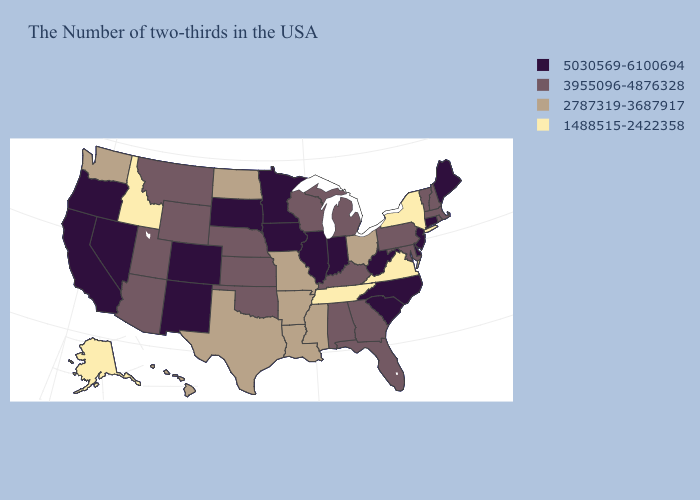Which states hav the highest value in the West?
Keep it brief. Colorado, New Mexico, Nevada, California, Oregon. What is the lowest value in the South?
Be succinct. 1488515-2422358. Name the states that have a value in the range 3955096-4876328?
Write a very short answer. Massachusetts, Rhode Island, New Hampshire, Vermont, Maryland, Pennsylvania, Florida, Georgia, Michigan, Kentucky, Alabama, Wisconsin, Kansas, Nebraska, Oklahoma, Wyoming, Utah, Montana, Arizona. Name the states that have a value in the range 2787319-3687917?
Write a very short answer. Ohio, Mississippi, Louisiana, Missouri, Arkansas, Texas, North Dakota, Washington, Hawaii. Which states have the lowest value in the West?
Be succinct. Idaho, Alaska. What is the value of Rhode Island?
Answer briefly. 3955096-4876328. Which states have the highest value in the USA?
Short answer required. Maine, Connecticut, New Jersey, Delaware, North Carolina, South Carolina, West Virginia, Indiana, Illinois, Minnesota, Iowa, South Dakota, Colorado, New Mexico, Nevada, California, Oregon. Name the states that have a value in the range 3955096-4876328?
Quick response, please. Massachusetts, Rhode Island, New Hampshire, Vermont, Maryland, Pennsylvania, Florida, Georgia, Michigan, Kentucky, Alabama, Wisconsin, Kansas, Nebraska, Oklahoma, Wyoming, Utah, Montana, Arizona. What is the value of Minnesota?
Short answer required. 5030569-6100694. Name the states that have a value in the range 5030569-6100694?
Give a very brief answer. Maine, Connecticut, New Jersey, Delaware, North Carolina, South Carolina, West Virginia, Indiana, Illinois, Minnesota, Iowa, South Dakota, Colorado, New Mexico, Nevada, California, Oregon. Name the states that have a value in the range 1488515-2422358?
Short answer required. New York, Virginia, Tennessee, Idaho, Alaska. What is the lowest value in the USA?
Give a very brief answer. 1488515-2422358. How many symbols are there in the legend?
Short answer required. 4. What is the highest value in the USA?
Give a very brief answer. 5030569-6100694. Does Montana have a lower value than Delaware?
Be succinct. Yes. 